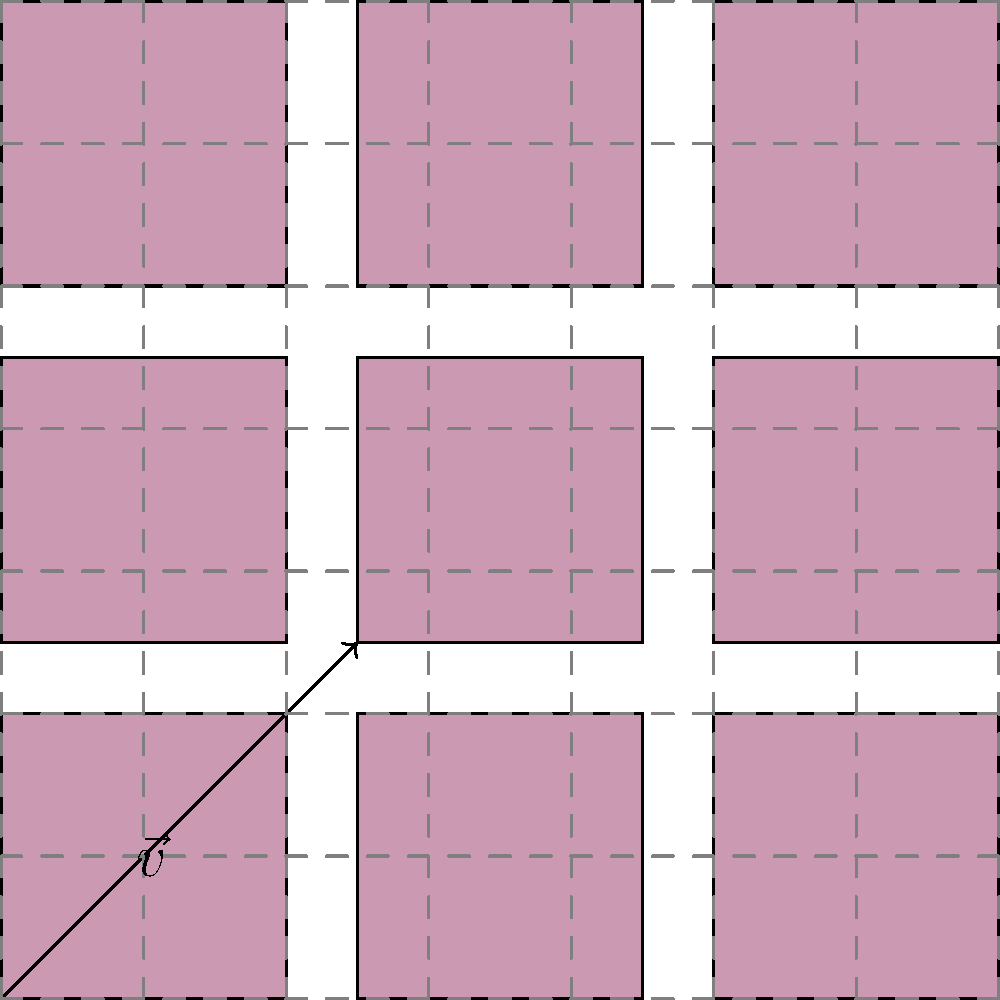You're creating a poster for Samia's "The Baby" album release party. To make a repeating pattern, you decide to translate the album cover artwork along a vector $\vec{v} = \langle 2.5, 2.5 \rangle$. If you apply this translation three times in both the x and y directions, how many complete album covers will appear on your poster (including the original)? Let's approach this step-by-step:

1) First, we need to understand what the translation vector $\vec{v} = \langle 2.5, 2.5 \rangle$ means. It moves the album cover 2.5 units to the right and 2.5 units up.

2) We're told that this translation is applied three times in both x and y directions. This creates a grid-like pattern.

3) To calculate the number of album covers, we need to count:
   - 1 for the original cover
   - 3 for the translations in the x-direction
   - 3 for the translations in the y-direction
   - The remaining covers formed by the combination of x and y translations

4) This forms a 4x4 grid (original + 3 translations in each direction)

5) The total number of album covers is therefore 4 * 4 = 16

6) We can verify this by counting the covers in the image: there are indeed 16 complete album covers visible.
Answer: 16 